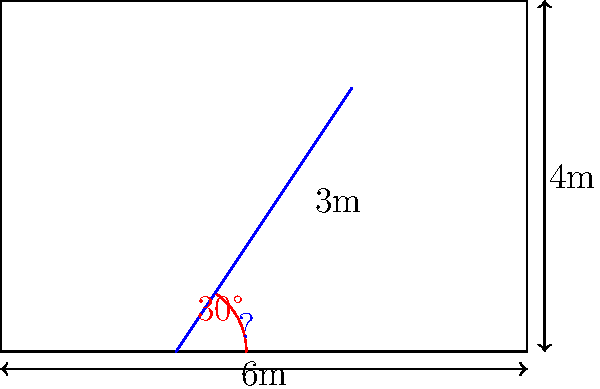In a recording studio, a sound-absorbing panel needs to be installed at a specific angle to optimize acoustic performance. The room has a width of 6 meters and a height of 4 meters. The panel extends from a point 2 meters from the left wall on the floor to a point 3 meters below the ceiling on the right wall. If the angle between the floor and the panel is 30°, what is the length of the panel to the nearest tenth of a meter? To find the length of the panel, we can use trigonometry. Let's approach this step-by-step:

1) First, we need to identify the right triangle formed by the panel and the floor. We know one angle (30°) and we need to find the hypotenuse (the panel length).

2) We can find the base and height of this triangle:
   Base = 6m - 2m = 4m (horizontal distance)
   Height = 4m - 3m = 1m (vertical distance)

3) Now we have a right triangle with base 4m and height 1m. We can use the Pythagorean theorem to find the length of the hypotenuse (panel):

   $c^2 = a^2 + b^2$
   $c^2 = 4^2 + 1^2$
   $c^2 = 16 + 1 = 17$
   $c = \sqrt{17}$

4) Calculate the square root:
   $\sqrt{17} \approx 4.12310562561766$

5) Rounding to the nearest tenth:
   4.12310562561766 ≈ 4.1 meters

Therefore, the length of the panel is approximately 4.1 meters.
Answer: 4.1 meters 